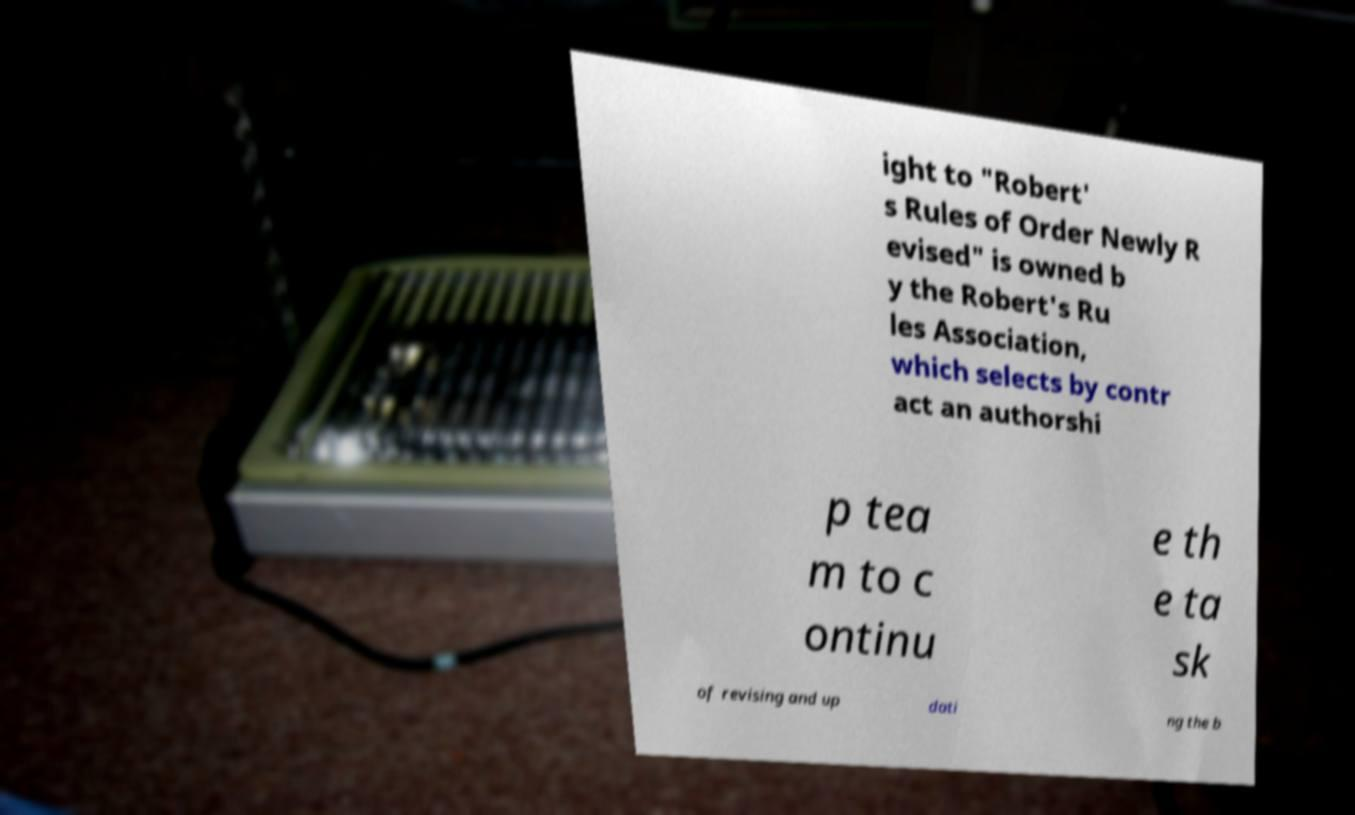Could you extract and type out the text from this image? ight to "Robert' s Rules of Order Newly R evised" is owned b y the Robert's Ru les Association, which selects by contr act an authorshi p tea m to c ontinu e th e ta sk of revising and up dati ng the b 